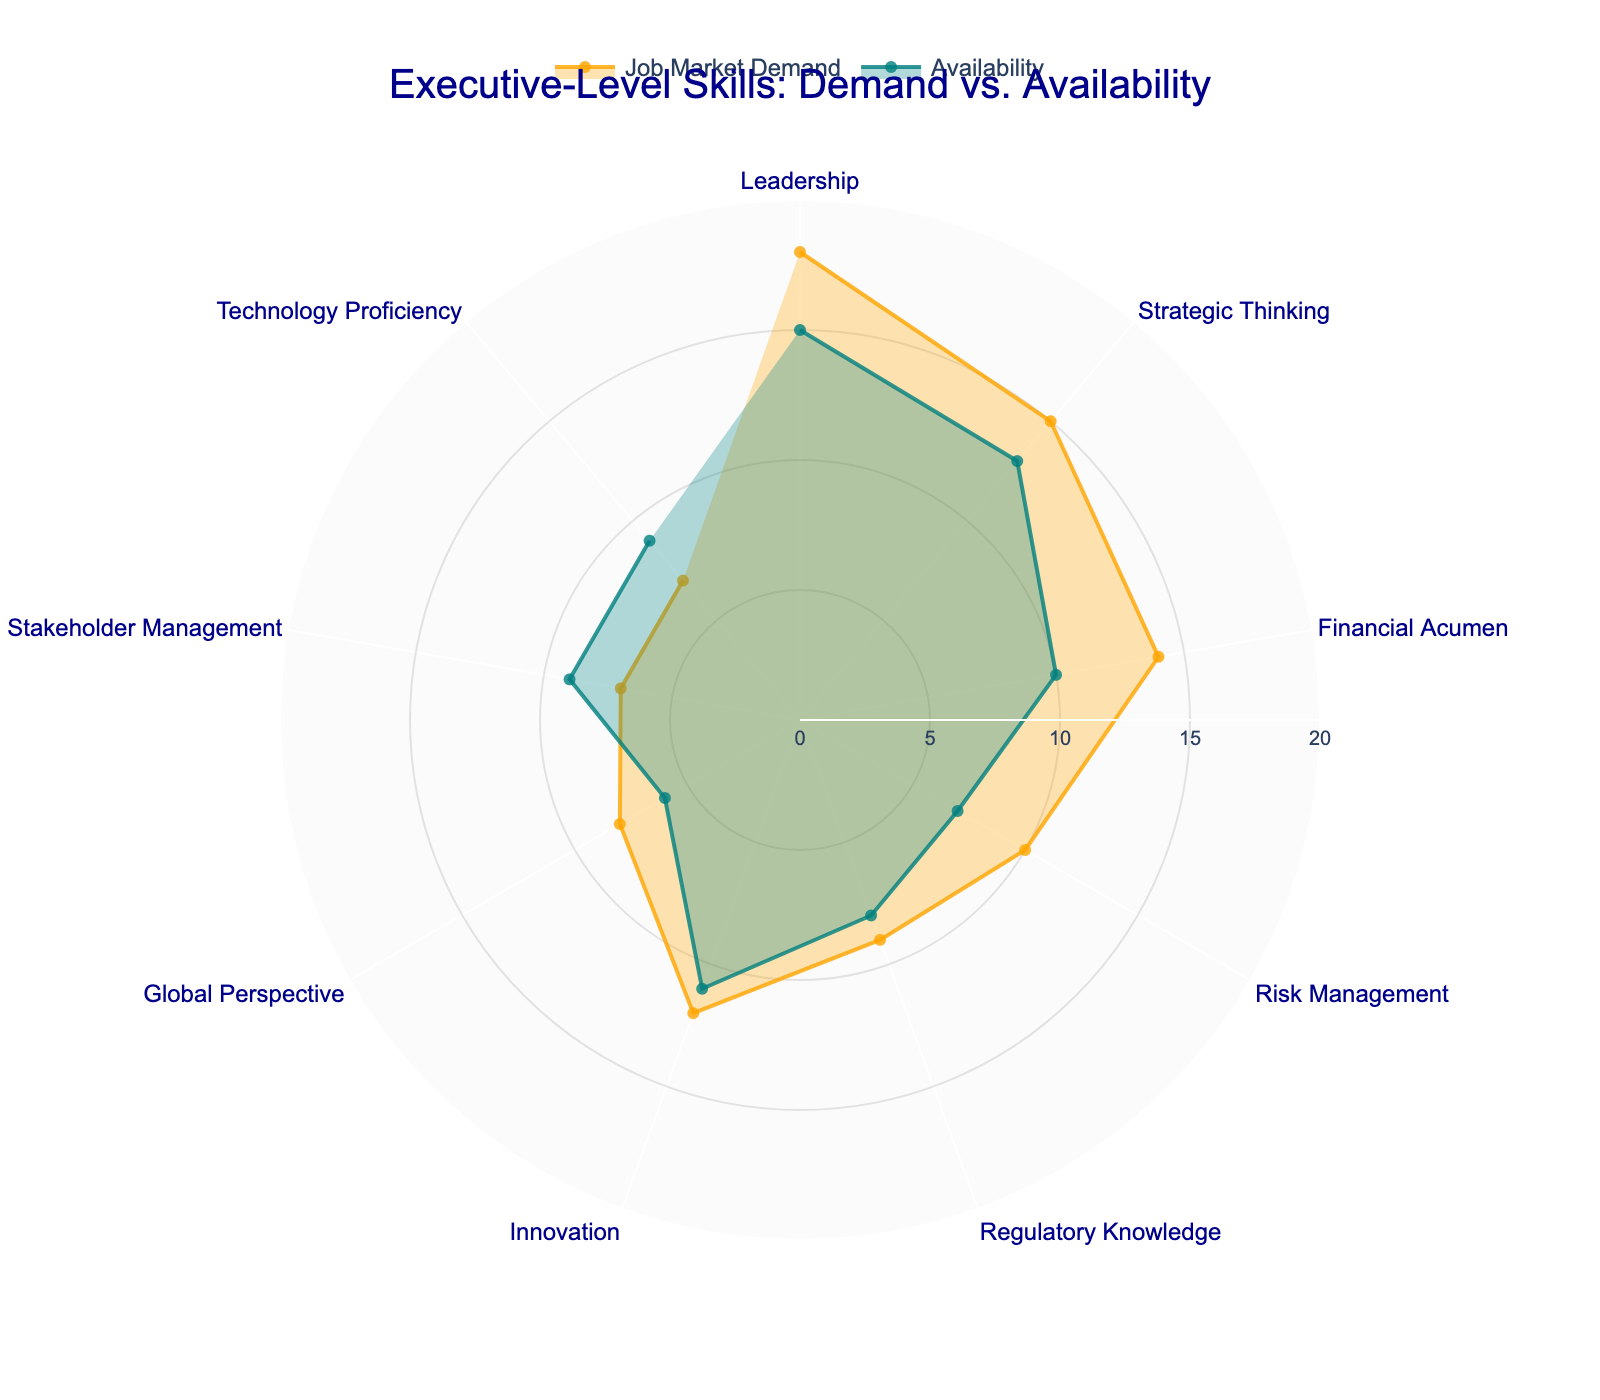What is the title of the polar area chart? The title of the chart is typically located at the top center in a readable font size and color for clear visibility.
Answer: Executive-Level Skills: Demand vs. Availability Which skill shows the highest job market demand? By identifying the length of the segments representing different skills, the skill with the longest segment for job market demand is the highest.
Answer: Leadership Which skill has the largest discrepancy between job market demand and availability? To find the skill with the largest discrepancy, calculate the difference for each skill and identify the maximum value.
Answer: Financial Acumen How many skills have a higher availability than job market demand? Compare the segments for availability and job market demand for each skill and count the number of skills where availability is higher.
Answer: 2 (Stakeholder Management, Technology Proficiency) What is the total percentage of job market demand for all skills combined? Sum up the job market demand percentages for all the skills.
Answer: 100% Which two skills have the closest values in job market demand? Identify the two skills with the most similar lengths in their job market demand segments by comparing their percentages.
Answer: Stakeholder Management and Technology Proficiency For which skill is the job market demand exactly three percentage points higher than availability? Calculate the difference between job market demand and availability for each skill and identify the skill where the difference is exactly three percentage points.
Answer: Risk Management Which skill has the least availability? Identify the skill represented by the shortest segment in availability.
Answer: Global Perspective 